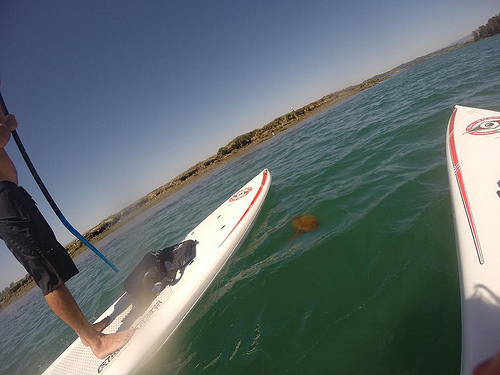<image>
Can you confirm if the sky is next to the mans foot? No. The sky is not positioned next to the mans foot. They are located in different areas of the scene. 